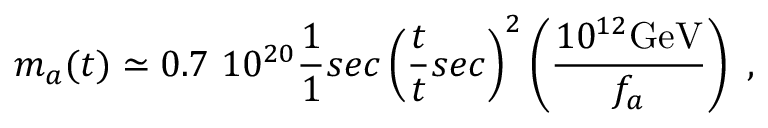<formula> <loc_0><loc_0><loc_500><loc_500>m _ { a } ( t ) \simeq 0 . 7 1 0 ^ { 2 0 } \frac { 1 } { 1 } { s e c } \left ( \frac { t } { t } { s e c } \right ) ^ { 2 } \left ( \frac { 1 0 ^ { 1 2 } G e V } { f _ { a } } \right ) \ ,</formula> 